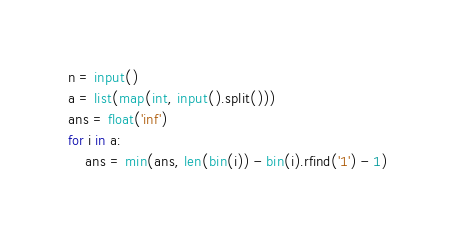Convert code to text. <code><loc_0><loc_0><loc_500><loc_500><_Python_>n = input()
a = list(map(int, input().split()))
ans = float('inf')
for i in a:
    ans = min(ans, len(bin(i)) - bin(i).rfind('1') - 1)</code> 